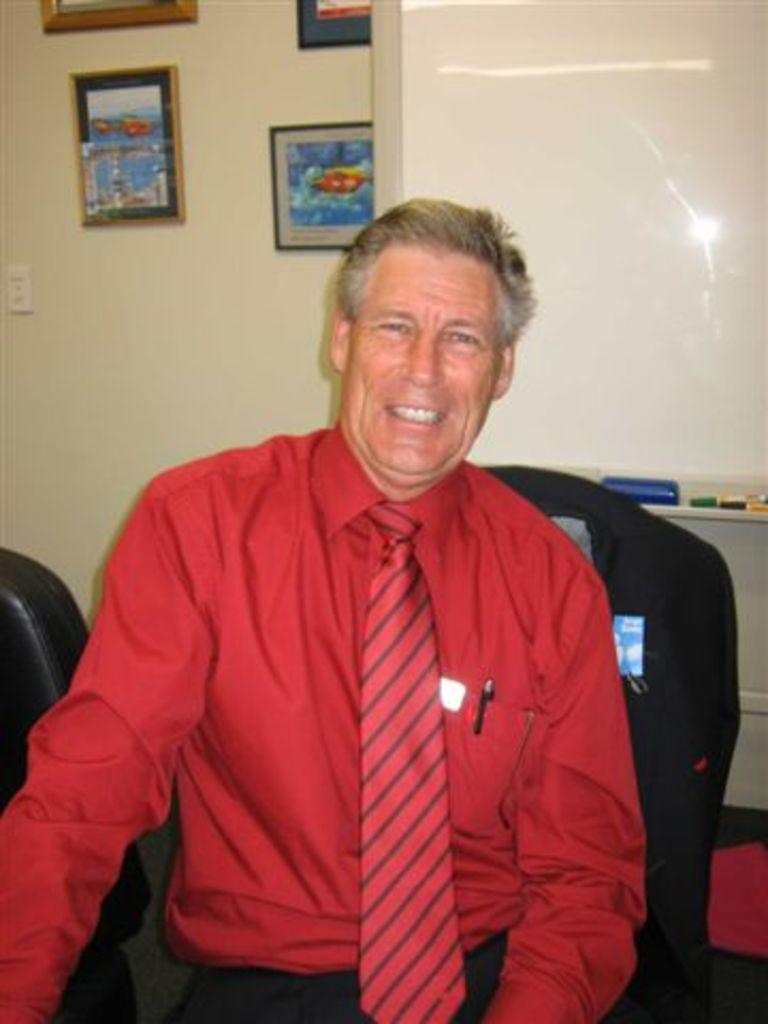Who or what is present in the image? There is a person in the image. What can be seen on the wall in the image? There are frames attached to the wall in the image. What type of snails are participating in the discussion in the image? There are no snails or discussions present in the image. 